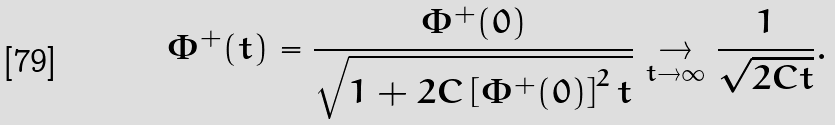Convert formula to latex. <formula><loc_0><loc_0><loc_500><loc_500>\Phi ^ { + } ( t ) = \frac { \Phi ^ { + } ( 0 ) } { \sqrt { 1 + 2 C \left [ \Phi ^ { + } ( 0 ) \right ] ^ { 2 } t } } \underset { t \to \infty } { \to } \frac { 1 } { \sqrt { 2 C t } } .</formula> 